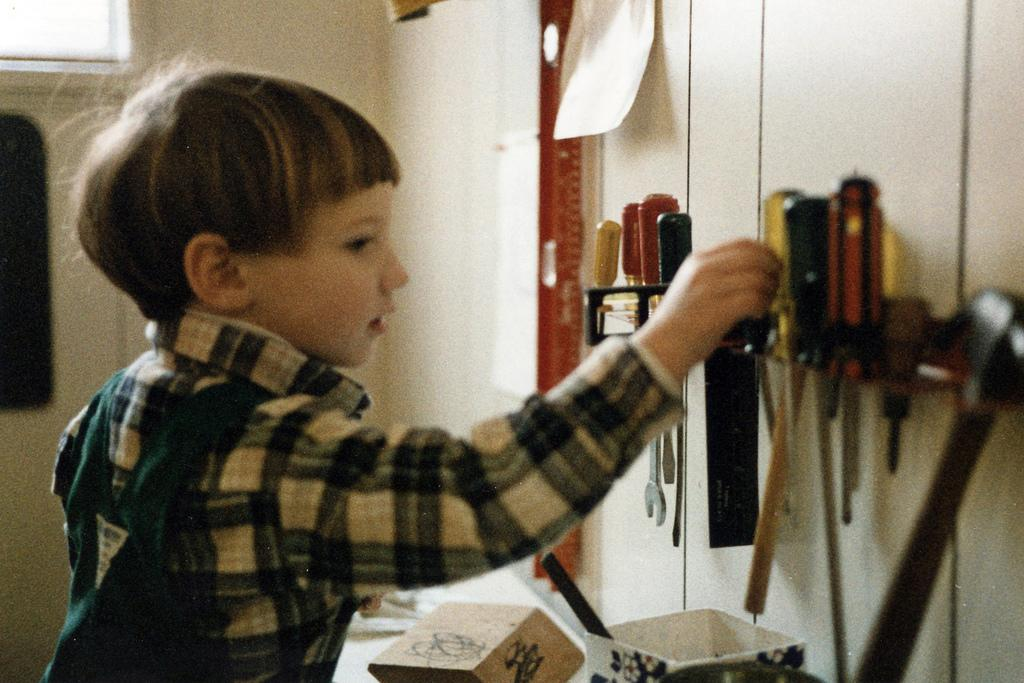Who is present in the image? There is a boy in the image. What can be seen hanging on the wall? There is a paper on the wall. What is the purpose of the rack in the image? The rack is used to hold tools. What objects can be found in the image that are typically used for storage? There is a box and a bowl in the image. What type of trains can be seen in the image? There are no trains present in the image. Can you describe the boy's hand in the image? The boy's hand is not visible in the image, so it cannot be described. 